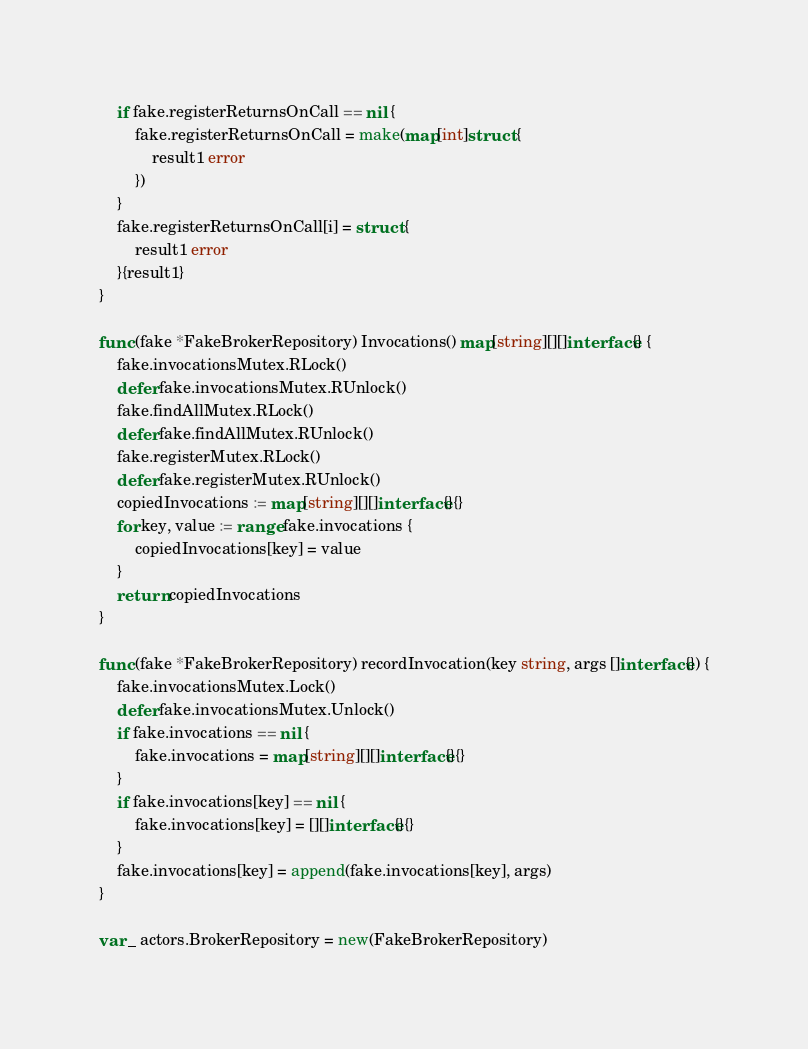<code> <loc_0><loc_0><loc_500><loc_500><_Go_>	if fake.registerReturnsOnCall == nil {
		fake.registerReturnsOnCall = make(map[int]struct {
			result1 error
		})
	}
	fake.registerReturnsOnCall[i] = struct {
		result1 error
	}{result1}
}

func (fake *FakeBrokerRepository) Invocations() map[string][][]interface{} {
	fake.invocationsMutex.RLock()
	defer fake.invocationsMutex.RUnlock()
	fake.findAllMutex.RLock()
	defer fake.findAllMutex.RUnlock()
	fake.registerMutex.RLock()
	defer fake.registerMutex.RUnlock()
	copiedInvocations := map[string][][]interface{}{}
	for key, value := range fake.invocations {
		copiedInvocations[key] = value
	}
	return copiedInvocations
}

func (fake *FakeBrokerRepository) recordInvocation(key string, args []interface{}) {
	fake.invocationsMutex.Lock()
	defer fake.invocationsMutex.Unlock()
	if fake.invocations == nil {
		fake.invocations = map[string][][]interface{}{}
	}
	if fake.invocations[key] == nil {
		fake.invocations[key] = [][]interface{}{}
	}
	fake.invocations[key] = append(fake.invocations[key], args)
}

var _ actors.BrokerRepository = new(FakeBrokerRepository)
</code> 